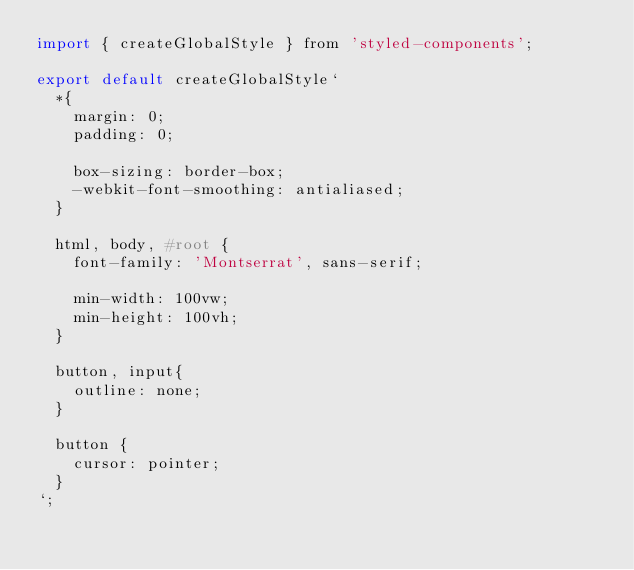Convert code to text. <code><loc_0><loc_0><loc_500><loc_500><_JavaScript_>import { createGlobalStyle } from 'styled-components';

export default createGlobalStyle`
  *{
    margin: 0;
    padding: 0;

    box-sizing: border-box;
    -webkit-font-smoothing: antialiased;
  }

  html, body, #root {
    font-family: 'Montserrat', sans-serif;

    min-width: 100vw;
    min-height: 100vh;
  }

  button, input{
    outline: none;
  }

  button {
    cursor: pointer;
  }
`;
</code> 